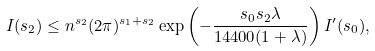<formula> <loc_0><loc_0><loc_500><loc_500>I ( s _ { 2 } ) \leq n ^ { s _ { 2 } } ( 2 \pi ) ^ { s _ { 1 } + s _ { 2 } } \exp \left ( - \frac { s _ { 0 } s _ { 2 } \lambda } { 1 4 4 0 0 ( 1 + \lambda ) } \right ) I ^ { \prime } ( s _ { 0 } ) ,</formula> 